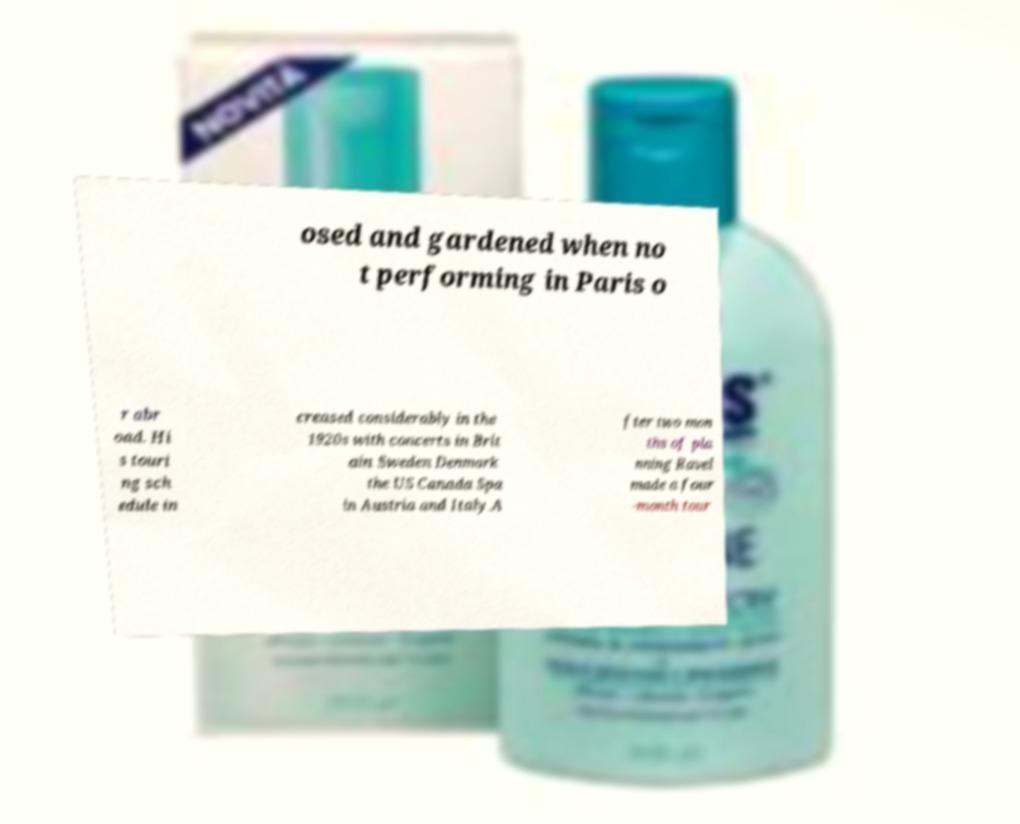For documentation purposes, I need the text within this image transcribed. Could you provide that? osed and gardened when no t performing in Paris o r abr oad. Hi s touri ng sch edule in creased considerably in the 1920s with concerts in Brit ain Sweden Denmark the US Canada Spa in Austria and Italy.A fter two mon ths of pla nning Ravel made a four -month tour 